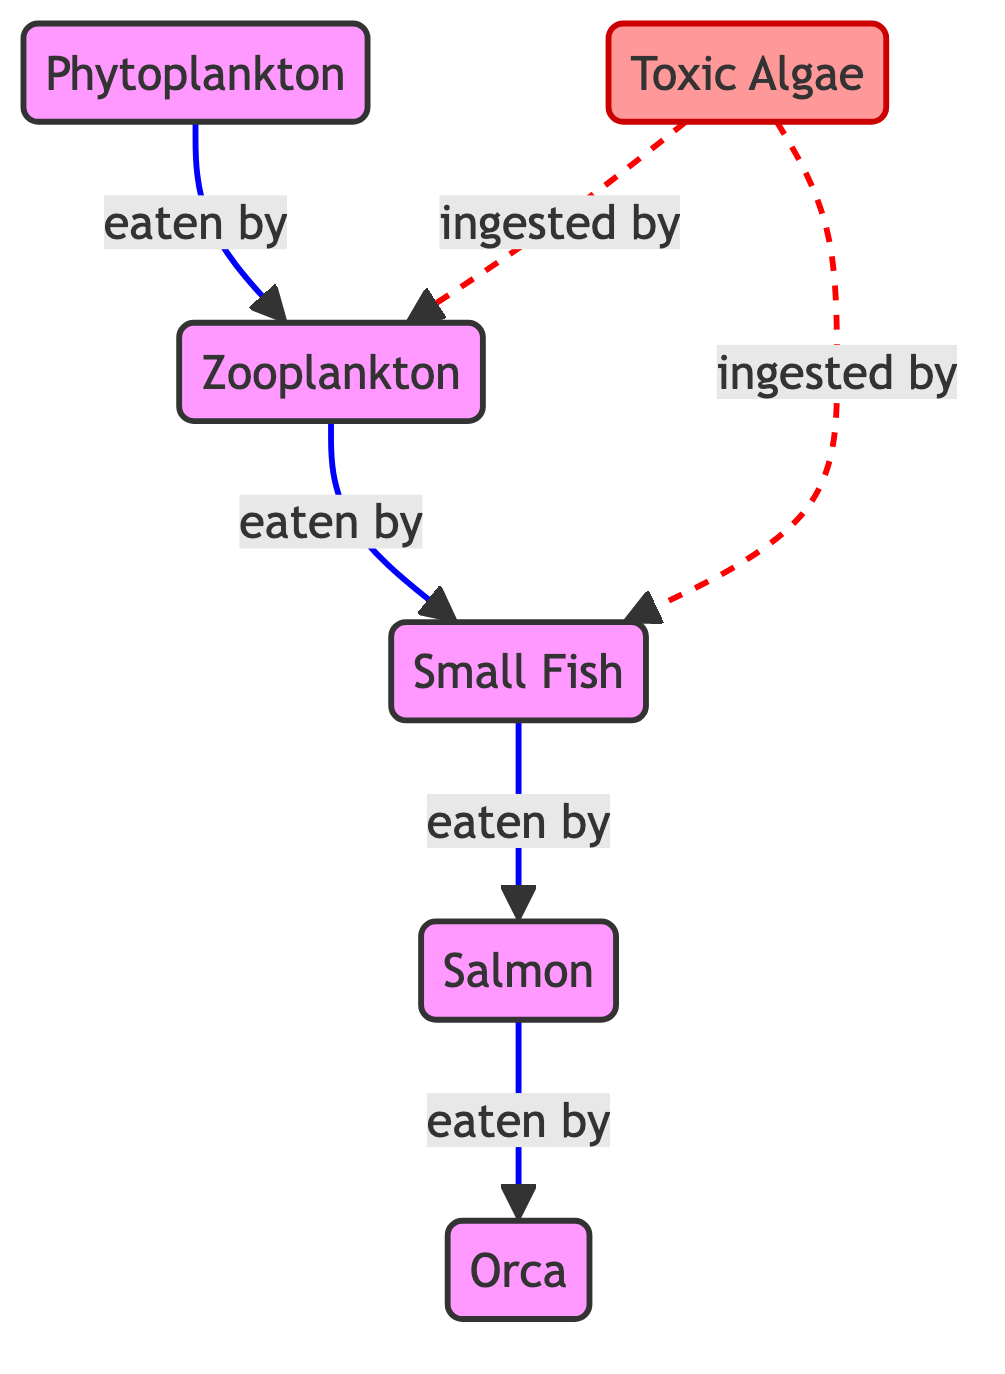What is the first node in the food chain? The first node in the food chain is "Phytoplankton," which is the starting point for the energy flow within this ecosystem.
Answer: Phytoplankton How many nodes are present in the food chain? There are five main nodes in the food chain: Phytoplankton, Zooplankton, Small Fish, Salmon, and Orca, plus one additional node for Toxic Algae, making a total of six.
Answer: Six Who eats the small fish? The "Salmon" node is shown as eating the small fish in the diagram, indicated by the directed flow from "Small Fish" to "Salmon."
Answer: Salmon What effect does toxic algae have on zooplankton? Toxic algae is ingested by zooplankton, as indicated by the dashed line in the diagram, showing a negative impact on that group.
Answer: Ingested What is the relationship between phytoplankton and zooplankton? The relationship is that zooplankton consume phytoplankton, as indicated by the solid arrow showing the flow from phytoplankton to zooplankton.
Answer: Eaten by How do toxic algae impact small fish? Toxic algae negatively impacts small fish by being ingested, which could harm the fish, as represented by the dashed line showing this interaction.
Answer: Ingested Which organism sits at the top of the food chain? The top predator in this food chain is the "Orca," which is the last node where energy flows.
Answer: Orca How does pollution affect the food chain? Pollution impacts the food chain primarily through toxic algae, which is presented in the diagram as affecting both small fish and zooplankton by being ingested, suggesting potential health risks.
Answer: Toxic Algae 